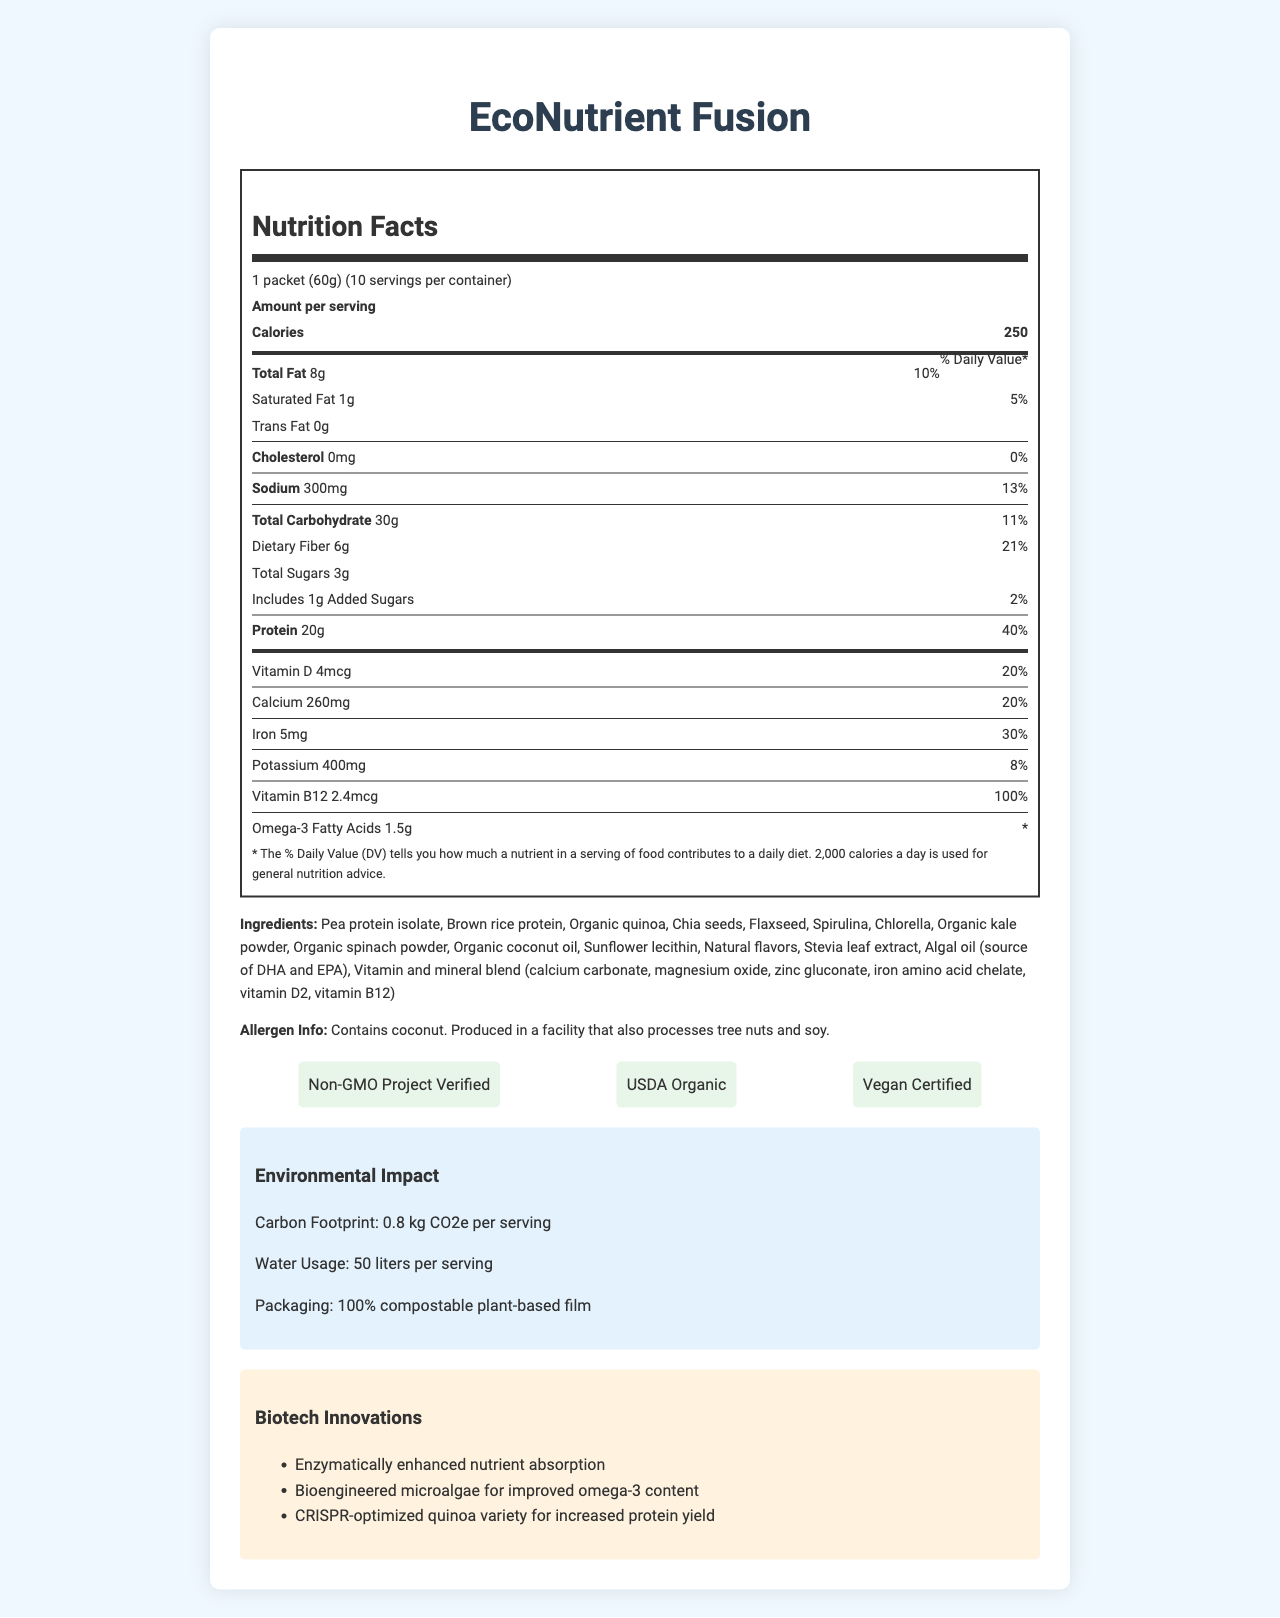what is the serving size of EcoNutrient Fusion? The serving size is displayed at the beginning of the Nutrition Facts section.
Answer: 1 packet (60g) how many servings are there per container? The number of servings per container is indicated right after the serving size.
Answer: 10 how many calories are in one serving? The calories per serving are shown under the "Amount per serving" section.
Answer: 250 what is the amount of total fat per serving? The total fat amount is listed following the calorie count.
Answer: 8g what percentage of the daily value for protein does one serving provide? The percentage daily value for protein is listed next to the protein amount.
Answer: 40% what is the main ingredient in EcoNutrient Fusion? The first ingredient listed is often the main ingredient.
Answer: Pea protein isolate what are the two main certifications displayed for the product? The certifications are highlighted in a section called "certifications."
Answer: Non-GMO Project Verified, USDA Organic which specific innovation enhances nutrient absorption? The biotech innovations section lists enzymatically enhanced nutrient absorption as one of the innovations.
Answer: Enzymatically enhanced nutrient absorption what is the carbon footprint per serving of the product? A. 0.5 kg CO2e B. 0.8 kg CO2e C. 1 kg CO2e The environmental impact section states the carbon footprint per serving as 0.8 kg CO2e.
Answer: B. 0.8 kg CO2e what are the total carbohydrates per serving of EcoNutrient Fusion? A. 15g B. 20g C. 30g D. 35g The total carbohydrates are listed under the carbohydrate section as 30g.
Answer: C. 30g does the product contain any cholesterol? The cholesterol value is shown as 0mg with a 0% daily value.
Answer: No is EcoNutrient Fusion vegan certified? The certifications section specifies that the product is Vegan Certified.
Answer: Yes summarize the main features and nutritional content of EcoNutrient Fusion. The document provides detailed nutritional information, ingredients, allergen info, certifications, environmental impact, and biotech innovations associated with the product EcoNutrient Fusion.
Answer: EcoNutrient Fusion is a sustainable, plant-based meal replacement with 250 calories per serving, 20g of protein, and numerous vitamins and minerals. It is certified Non-GMO, USDA Organic, and Vegan, and has a low carbon footprint and water usage. The product includes advanced biotechnological innovations like enhanced nutrient absorption and CRISPR-optimized quinoa. what specific CRISPR innovation is mentioned in the document? The document does not provide specific details about the CRISPR optimization process for quinoa.
Answer: Not enough information 